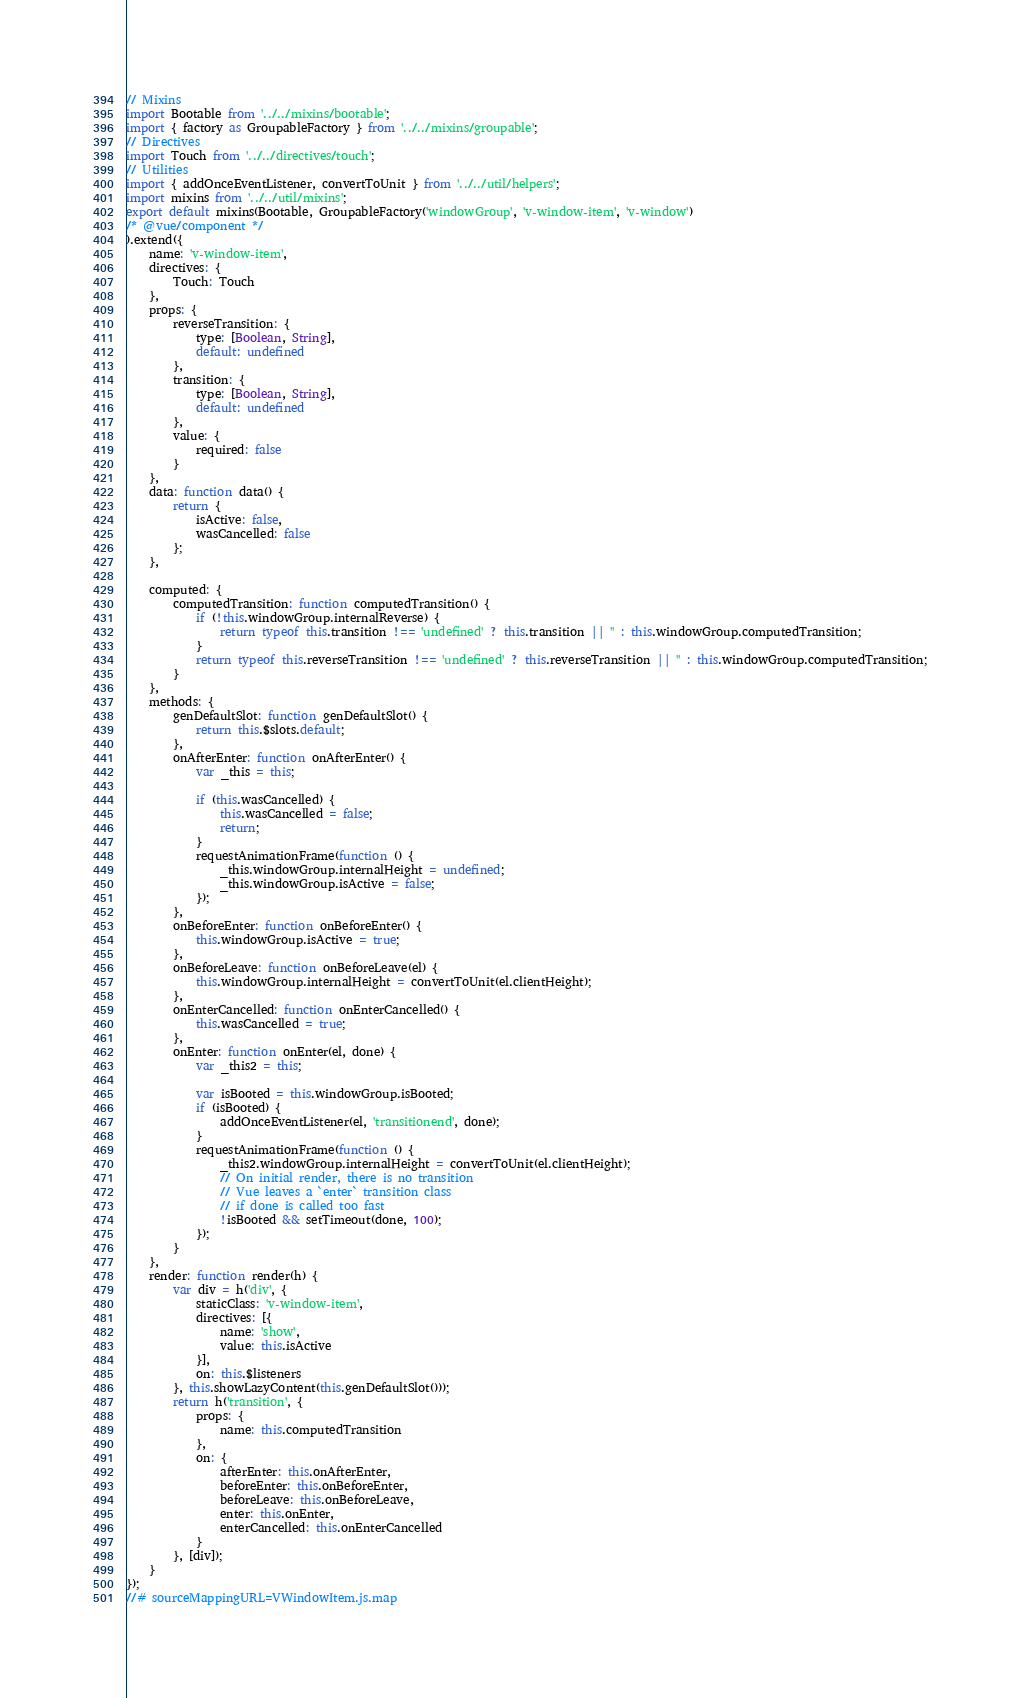Convert code to text. <code><loc_0><loc_0><loc_500><loc_500><_JavaScript_>// Mixins
import Bootable from '../../mixins/bootable';
import { factory as GroupableFactory } from '../../mixins/groupable';
// Directives
import Touch from '../../directives/touch';
// Utilities
import { addOnceEventListener, convertToUnit } from '../../util/helpers';
import mixins from '../../util/mixins';
export default mixins(Bootable, GroupableFactory('windowGroup', 'v-window-item', 'v-window')
/* @vue/component */
).extend({
    name: 'v-window-item',
    directives: {
        Touch: Touch
    },
    props: {
        reverseTransition: {
            type: [Boolean, String],
            default: undefined
        },
        transition: {
            type: [Boolean, String],
            default: undefined
        },
        value: {
            required: false
        }
    },
    data: function data() {
        return {
            isActive: false,
            wasCancelled: false
        };
    },

    computed: {
        computedTransition: function computedTransition() {
            if (!this.windowGroup.internalReverse) {
                return typeof this.transition !== 'undefined' ? this.transition || '' : this.windowGroup.computedTransition;
            }
            return typeof this.reverseTransition !== 'undefined' ? this.reverseTransition || '' : this.windowGroup.computedTransition;
        }
    },
    methods: {
        genDefaultSlot: function genDefaultSlot() {
            return this.$slots.default;
        },
        onAfterEnter: function onAfterEnter() {
            var _this = this;

            if (this.wasCancelled) {
                this.wasCancelled = false;
                return;
            }
            requestAnimationFrame(function () {
                _this.windowGroup.internalHeight = undefined;
                _this.windowGroup.isActive = false;
            });
        },
        onBeforeEnter: function onBeforeEnter() {
            this.windowGroup.isActive = true;
        },
        onBeforeLeave: function onBeforeLeave(el) {
            this.windowGroup.internalHeight = convertToUnit(el.clientHeight);
        },
        onEnterCancelled: function onEnterCancelled() {
            this.wasCancelled = true;
        },
        onEnter: function onEnter(el, done) {
            var _this2 = this;

            var isBooted = this.windowGroup.isBooted;
            if (isBooted) {
                addOnceEventListener(el, 'transitionend', done);
            }
            requestAnimationFrame(function () {
                _this2.windowGroup.internalHeight = convertToUnit(el.clientHeight);
                // On initial render, there is no transition
                // Vue leaves a `enter` transition class
                // if done is called too fast
                !isBooted && setTimeout(done, 100);
            });
        }
    },
    render: function render(h) {
        var div = h('div', {
            staticClass: 'v-window-item',
            directives: [{
                name: 'show',
                value: this.isActive
            }],
            on: this.$listeners
        }, this.showLazyContent(this.genDefaultSlot()));
        return h('transition', {
            props: {
                name: this.computedTransition
            },
            on: {
                afterEnter: this.onAfterEnter,
                beforeEnter: this.onBeforeEnter,
                beforeLeave: this.onBeforeLeave,
                enter: this.onEnter,
                enterCancelled: this.onEnterCancelled
            }
        }, [div]);
    }
});
//# sourceMappingURL=VWindowItem.js.map</code> 